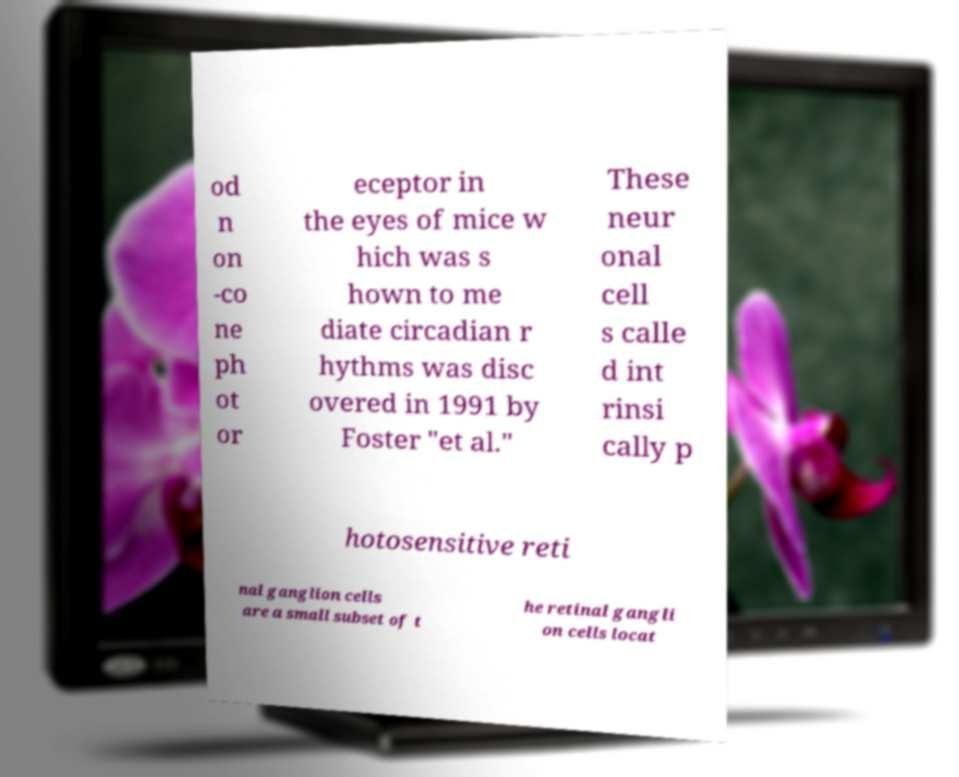Please identify and transcribe the text found in this image. od n on -co ne ph ot or eceptor in the eyes of mice w hich was s hown to me diate circadian r hythms was disc overed in 1991 by Foster "et al." These neur onal cell s calle d int rinsi cally p hotosensitive reti nal ganglion cells are a small subset of t he retinal gangli on cells locat 